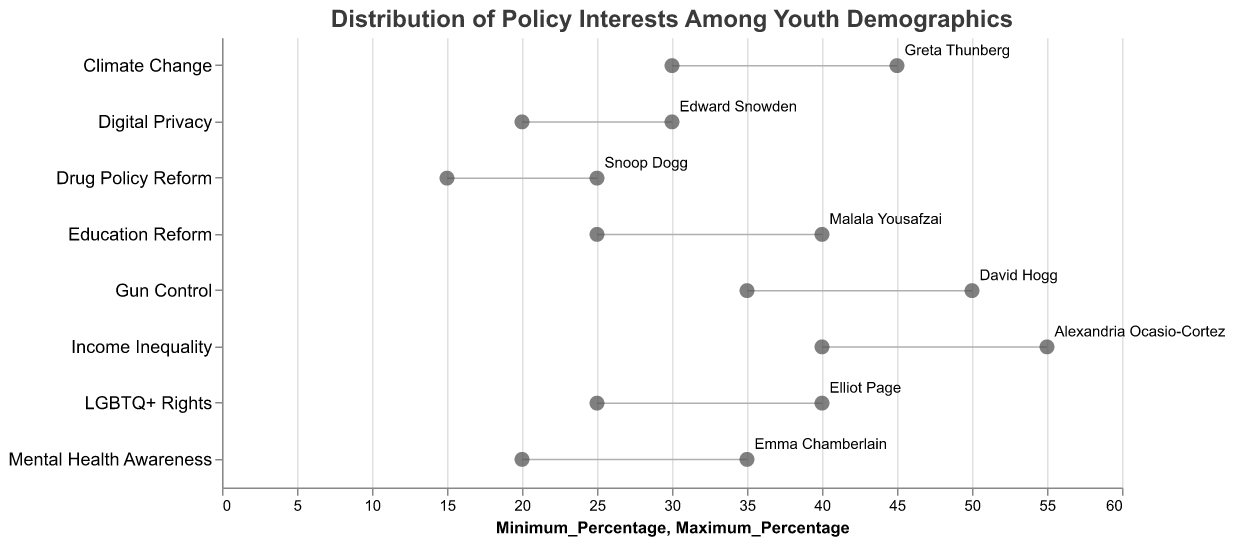Which policy has the highest maximum percentage of interest among youth demographics? The policy with the highest maximum percentage can be identified by looking for the highest point on the x-axis. Income Inequality has a maximum percentage of 55.
Answer: Income Inequality Who is the influencer associated with the policy having the lowest minimum percentage of interest? To find the lowest minimum percentage, identify the point closest to the origin on the x-axis. Drug Policy Reform has the lowest minimum percentage of 15, associated with Snoop Dogg.
Answer: Snoop Dogg What is the average range of interest for Mental Health Awareness? The range of interest is calculated by subtracting the minimum percentage from the maximum percentage for Mental Health Awareness: 35 - 20 = 15.
Answer: 15 Which policy has a greater maximum percentage of interest, Gun Control or Education Reform? Compare the maximum percentages for both policies: Gun Control (50) and Education Reform (40). Gun Control has the greater maximum percentage.
Answer: Gun Control Among the policies with a minimum interest percentage of 20%, which one has the smallest range? Identify the policies with a minimum percentage of 20% (Mental Health Awareness and Digital Privacy). Calculate the ranges: Mental Health Awareness (35-20=15) and Digital Privacy (30-20=10). Digital Privacy has the smallest range.
Answer: Digital Privacy What is the total span of percentages for Income Inequality? The span is given by the difference between the maximum and minimum percentages of Income Inequality: 55 - 40 = 15.
Answer: 15 Which policy has the smallest difference between its minimum and maximum percentage of youth interest? Calculate the difference for each policy and identify the smallest: Drug Policy Reform has a difference of 10 (25 - 15).
Answer: Drug Policy Reform For Education Reform, what is the maximum percentage increase in interest compared to Climate Change? Compare the maximum percentages: Climate Change (45) and Education Reform (40). The maximum increase would be 45 - 40 = 5.
Answer: 5 How many policies have a maximum percentage of interest greater than 40%? Identify the policies with maximum percentages over 40%: Climate Change, Income Inequality, and Gun Control. There are 3 such policies.
Answer: 3 What is the combined minimum percentage of interest for Gun Control and Mental Health Awareness? Add the minimum percentages for both policies: Gun Control (35) and Mental Health Awareness (20). The combined minimum percentage is 35 + 20 = 55.
Answer: 55 